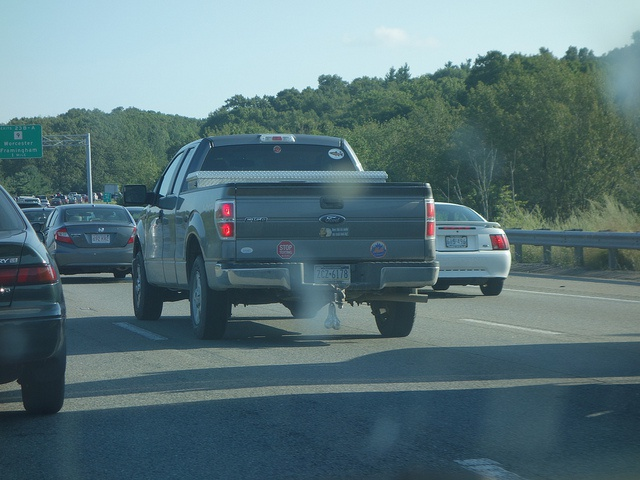Describe the objects in this image and their specific colors. I can see truck in lightblue, blue, gray, and darkblue tones, car in lightblue, black, blue, darkblue, and gray tones, car in lightblue, gray, darkblue, teal, and darkgray tones, car in lightblue, blue, gray, and black tones, and car in lightblue, blue, darkblue, navy, and gray tones in this image. 